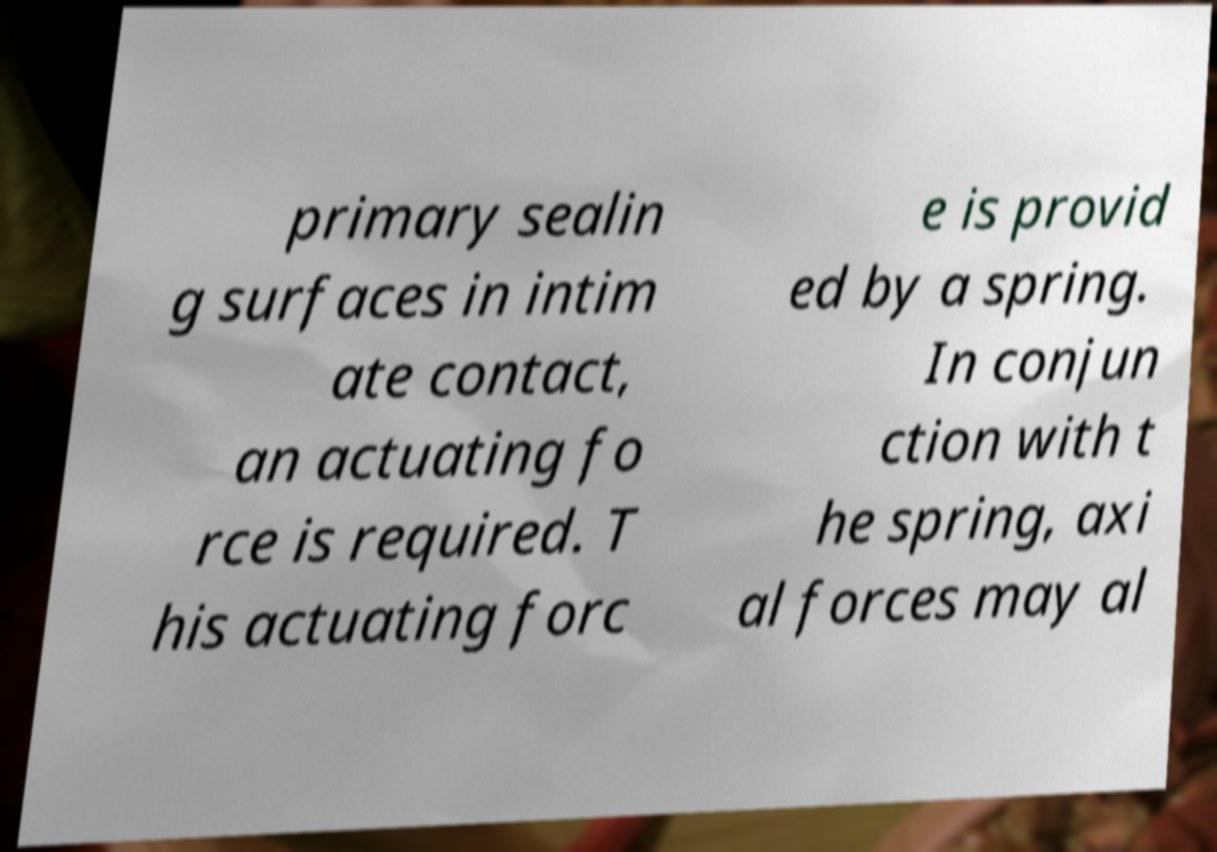Please identify and transcribe the text found in this image. primary sealin g surfaces in intim ate contact, an actuating fo rce is required. T his actuating forc e is provid ed by a spring. In conjun ction with t he spring, axi al forces may al 